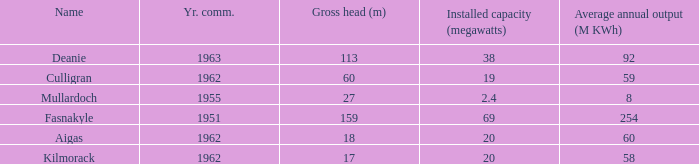What is the Year Commissioned of the power stationo with a Gross head of less than 18? 1962.0. Could you parse the entire table? {'header': ['Name', 'Yr. comm.', 'Gross head (m)', 'Installed capacity (megawatts)', 'Average annual output (M KWh)'], 'rows': [['Deanie', '1963', '113', '38', '92'], ['Culligran', '1962', '60', '19', '59'], ['Mullardoch', '1955', '27', '2.4', '8'], ['Fasnakyle', '1951', '159', '69', '254'], ['Aigas', '1962', '18', '20', '60'], ['Kilmorack', '1962', '17', '20', '58']]} 